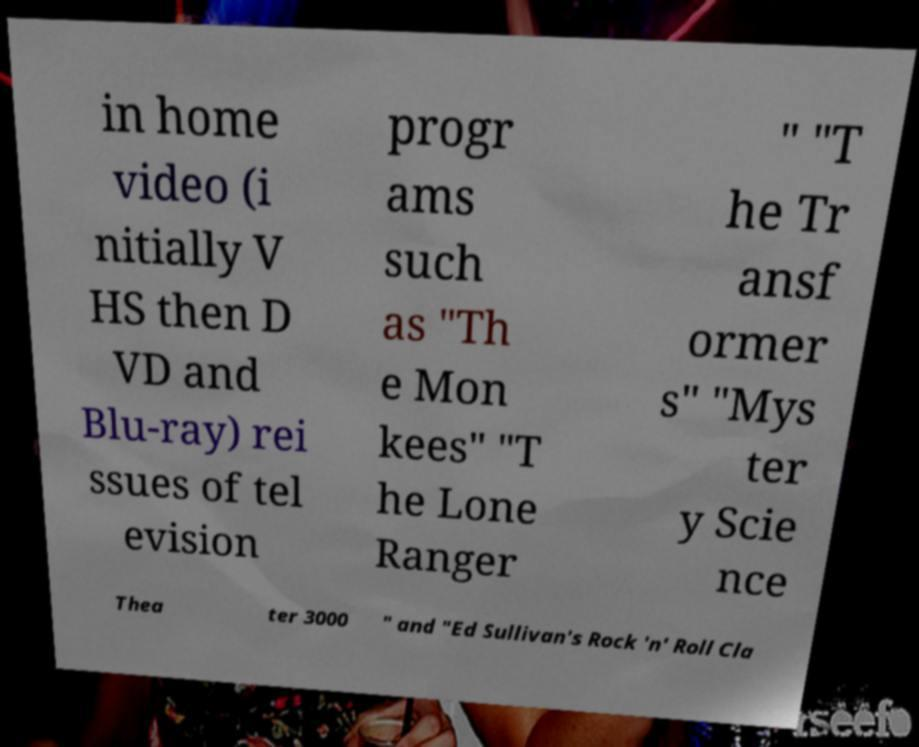Please read and relay the text visible in this image. What does it say? in home video (i nitially V HS then D VD and Blu-ray) rei ssues of tel evision progr ams such as "Th e Mon kees" "T he Lone Ranger " "T he Tr ansf ormer s" "Mys ter y Scie nce Thea ter 3000 " and "Ed Sullivan's Rock 'n' Roll Cla 